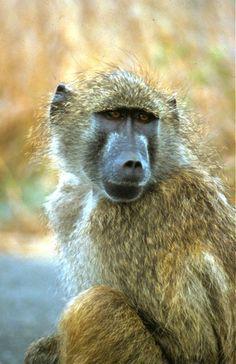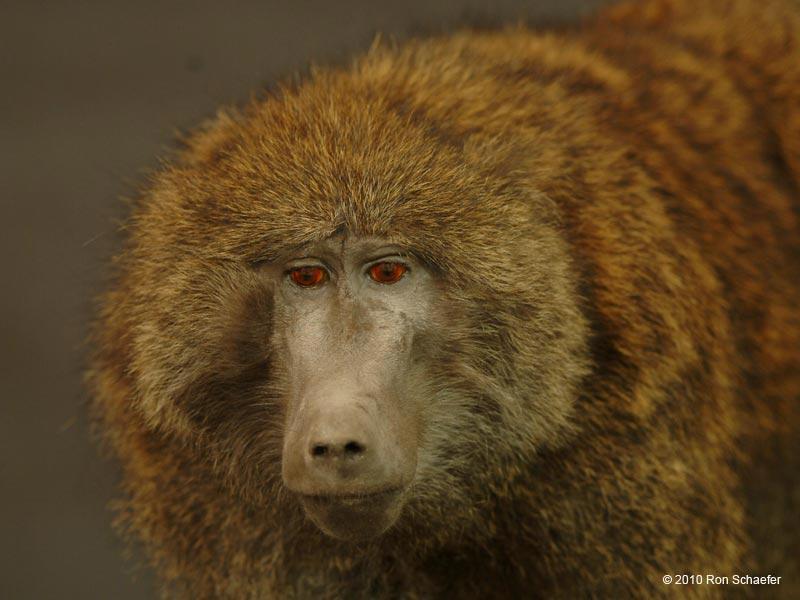The first image is the image on the left, the second image is the image on the right. Analyze the images presented: Is the assertion "The monkey in the left hand image has creepy red eyes." valid? Answer yes or no. No. 